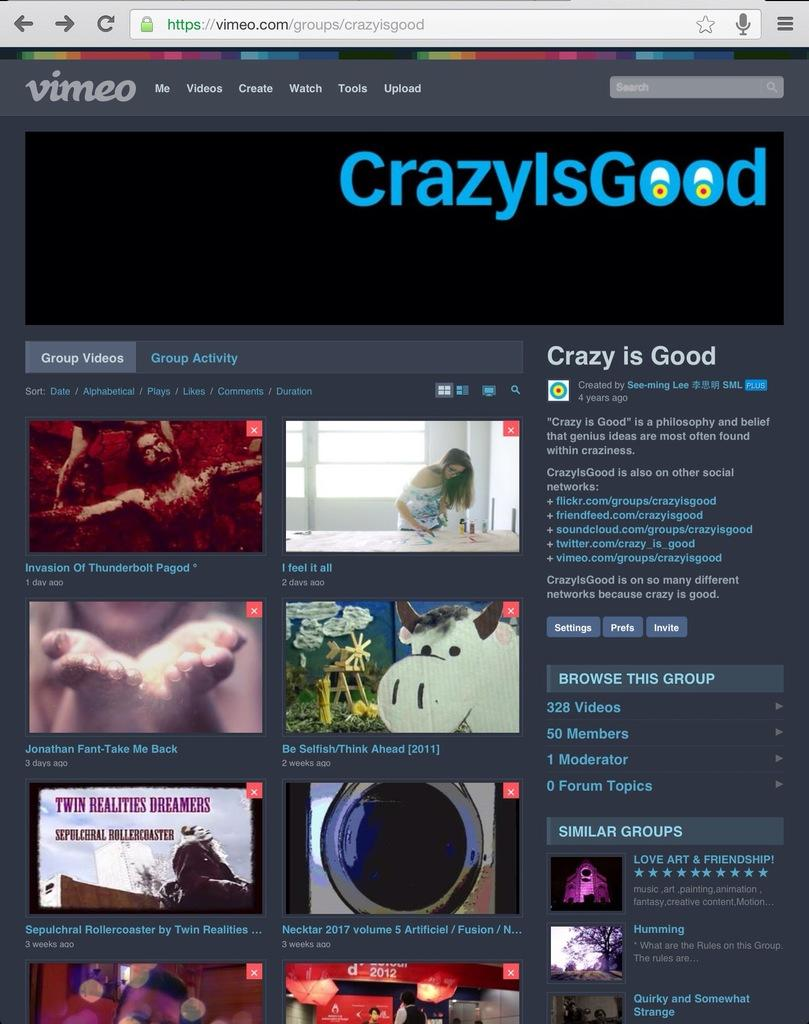<image>
Provide a brief description of the given image. A Vimeo web page displays content for a page titled "CrazyIsGood". 